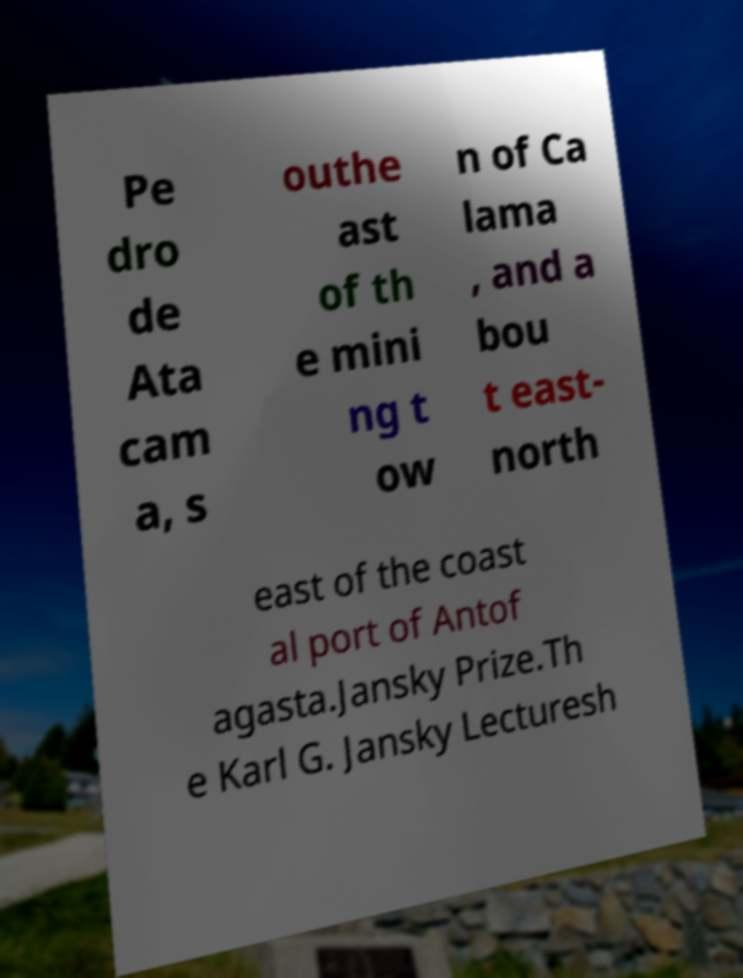What messages or text are displayed in this image? I need them in a readable, typed format. Pe dro de Ata cam a, s outhe ast of th e mini ng t ow n of Ca lama , and a bou t east- north east of the coast al port of Antof agasta.Jansky Prize.Th e Karl G. Jansky Lecturesh 